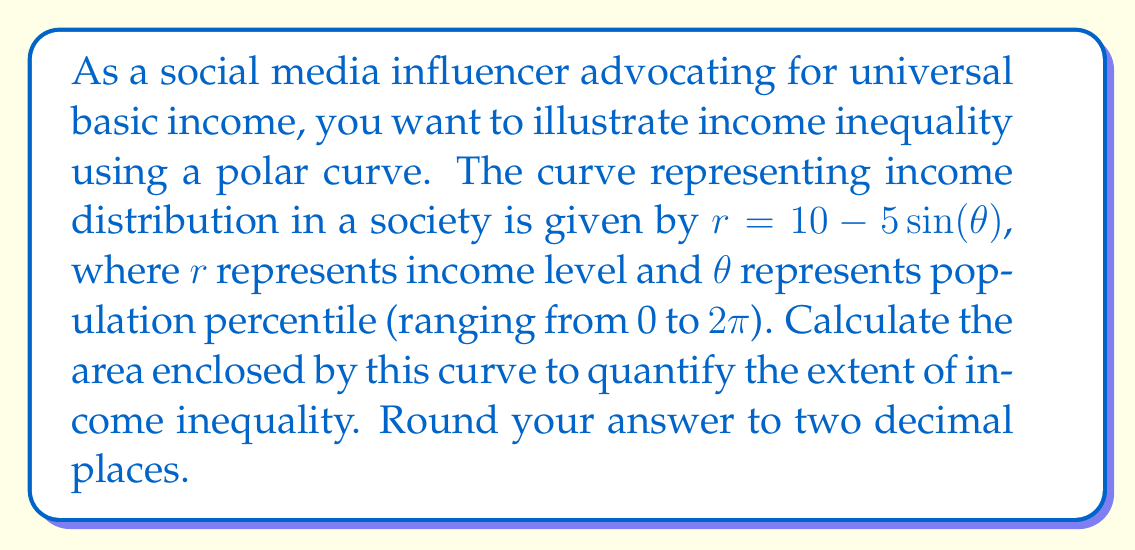Help me with this question. To calculate the area enclosed by a polar curve, we use the formula:

$$ A = \frac{1}{2} \int_0^{2\pi} r^2 d\theta $$

Given the curve $r = 10 - 5\sin(\theta)$, we need to square this function:

$$ r^2 = (10 - 5\sin(\theta))^2 = 100 - 100\sin(\theta) + 25\sin^2(\theta) $$

Now, let's substitute this into our area formula:

$$ A = \frac{1}{2} \int_0^{2\pi} (100 - 100\sin(\theta) + 25\sin^2(\theta)) d\theta $$

We can split this integral into three parts:

$$ A = \frac{1}{2} \left[ 100 \int_0^{2\pi} d\theta - 100 \int_0^{2\pi} \sin(\theta) d\theta + 25 \int_0^{2\pi} \sin^2(\theta) d\theta \right] $$

Evaluating each integral:

1. $\int_0^{2\pi} d\theta = 2\pi$
2. $\int_0^{2\pi} \sin(\theta) d\theta = [-\cos(\theta)]_0^{2\pi} = 0$
3. $\int_0^{2\pi} \sin^2(\theta) d\theta = [\frac{\theta}{2} - \frac{\sin(2\theta)}{4}]_0^{2\pi} = \pi$

Substituting these results:

$$ A = \frac{1}{2} [100(2\pi) - 100(0) + 25(\pi)] $$
$$ A = \frac{1}{2} [200\pi + 25\pi] $$
$$ A = \frac{225\pi}{2} $$

Calculating this value and rounding to two decimal places:

$$ A \approx 353.43 $$

This area represents the total income distribution in the society, with larger areas indicating greater income inequality.
Answer: $353.43$ square units 